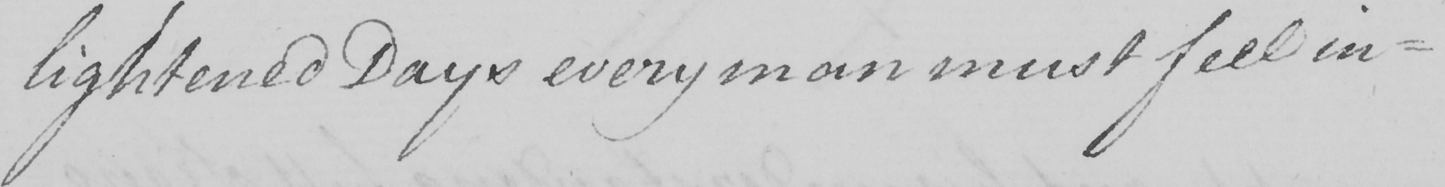What text is written in this handwritten line? lightened Days every man must feel in- 